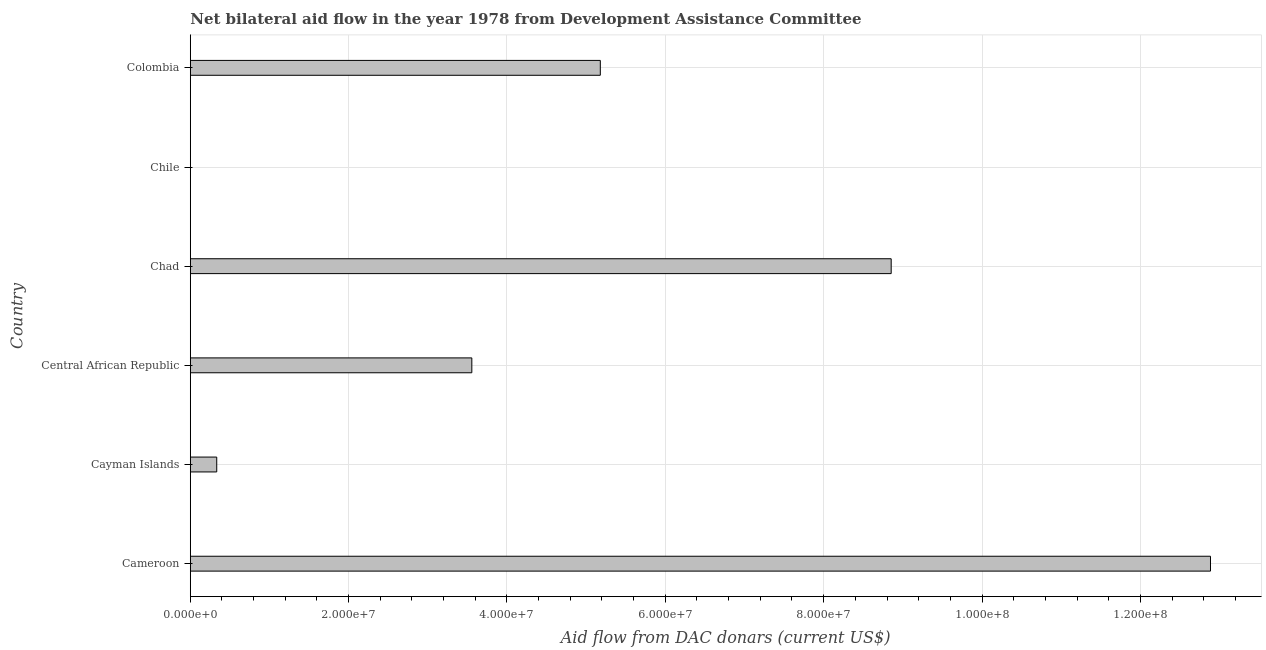Does the graph contain grids?
Offer a very short reply. Yes. What is the title of the graph?
Your answer should be very brief. Net bilateral aid flow in the year 1978 from Development Assistance Committee. What is the label or title of the X-axis?
Ensure brevity in your answer.  Aid flow from DAC donars (current US$). What is the label or title of the Y-axis?
Your answer should be compact. Country. What is the net bilateral aid flows from dac donors in Chad?
Provide a short and direct response. 8.85e+07. Across all countries, what is the maximum net bilateral aid flows from dac donors?
Your answer should be compact. 1.29e+08. Across all countries, what is the minimum net bilateral aid flows from dac donors?
Your answer should be compact. 0. In which country was the net bilateral aid flows from dac donors maximum?
Ensure brevity in your answer.  Cameroon. What is the sum of the net bilateral aid flows from dac donors?
Your response must be concise. 3.08e+08. What is the difference between the net bilateral aid flows from dac donors in Cameroon and Cayman Islands?
Offer a terse response. 1.26e+08. What is the average net bilateral aid flows from dac donors per country?
Ensure brevity in your answer.  5.13e+07. What is the median net bilateral aid flows from dac donors?
Make the answer very short. 4.37e+07. In how many countries, is the net bilateral aid flows from dac donors greater than 88000000 US$?
Make the answer very short. 2. What is the ratio of the net bilateral aid flows from dac donors in Cameroon to that in Cayman Islands?
Make the answer very short. 38.58. What is the difference between the highest and the second highest net bilateral aid flows from dac donors?
Your response must be concise. 4.03e+07. Is the sum of the net bilateral aid flows from dac donors in Cameroon and Chad greater than the maximum net bilateral aid flows from dac donors across all countries?
Keep it short and to the point. Yes. What is the difference between the highest and the lowest net bilateral aid flows from dac donors?
Make the answer very short. 1.29e+08. In how many countries, is the net bilateral aid flows from dac donors greater than the average net bilateral aid flows from dac donors taken over all countries?
Your answer should be very brief. 3. What is the difference between two consecutive major ticks on the X-axis?
Your response must be concise. 2.00e+07. What is the Aid flow from DAC donars (current US$) of Cameroon?
Provide a succinct answer. 1.29e+08. What is the Aid flow from DAC donars (current US$) in Cayman Islands?
Provide a short and direct response. 3.34e+06. What is the Aid flow from DAC donars (current US$) of Central African Republic?
Keep it short and to the point. 3.56e+07. What is the Aid flow from DAC donars (current US$) in Chad?
Give a very brief answer. 8.85e+07. What is the Aid flow from DAC donars (current US$) in Chile?
Ensure brevity in your answer.  0. What is the Aid flow from DAC donars (current US$) in Colombia?
Provide a short and direct response. 5.18e+07. What is the difference between the Aid flow from DAC donars (current US$) in Cameroon and Cayman Islands?
Provide a short and direct response. 1.26e+08. What is the difference between the Aid flow from DAC donars (current US$) in Cameroon and Central African Republic?
Offer a terse response. 9.33e+07. What is the difference between the Aid flow from DAC donars (current US$) in Cameroon and Chad?
Keep it short and to the point. 4.03e+07. What is the difference between the Aid flow from DAC donars (current US$) in Cameroon and Colombia?
Provide a short and direct response. 7.71e+07. What is the difference between the Aid flow from DAC donars (current US$) in Cayman Islands and Central African Republic?
Your response must be concise. -3.22e+07. What is the difference between the Aid flow from DAC donars (current US$) in Cayman Islands and Chad?
Keep it short and to the point. -8.52e+07. What is the difference between the Aid flow from DAC donars (current US$) in Cayman Islands and Colombia?
Ensure brevity in your answer.  -4.84e+07. What is the difference between the Aid flow from DAC donars (current US$) in Central African Republic and Chad?
Make the answer very short. -5.30e+07. What is the difference between the Aid flow from DAC donars (current US$) in Central African Republic and Colombia?
Offer a very short reply. -1.62e+07. What is the difference between the Aid flow from DAC donars (current US$) in Chad and Colombia?
Your answer should be very brief. 3.67e+07. What is the ratio of the Aid flow from DAC donars (current US$) in Cameroon to that in Cayman Islands?
Ensure brevity in your answer.  38.58. What is the ratio of the Aid flow from DAC donars (current US$) in Cameroon to that in Central African Republic?
Keep it short and to the point. 3.62. What is the ratio of the Aid flow from DAC donars (current US$) in Cameroon to that in Chad?
Your answer should be very brief. 1.46. What is the ratio of the Aid flow from DAC donars (current US$) in Cameroon to that in Colombia?
Ensure brevity in your answer.  2.49. What is the ratio of the Aid flow from DAC donars (current US$) in Cayman Islands to that in Central African Republic?
Your response must be concise. 0.09. What is the ratio of the Aid flow from DAC donars (current US$) in Cayman Islands to that in Chad?
Provide a succinct answer. 0.04. What is the ratio of the Aid flow from DAC donars (current US$) in Cayman Islands to that in Colombia?
Ensure brevity in your answer.  0.06. What is the ratio of the Aid flow from DAC donars (current US$) in Central African Republic to that in Chad?
Ensure brevity in your answer.  0.4. What is the ratio of the Aid flow from DAC donars (current US$) in Central African Republic to that in Colombia?
Offer a very short reply. 0.69. What is the ratio of the Aid flow from DAC donars (current US$) in Chad to that in Colombia?
Offer a terse response. 1.71. 